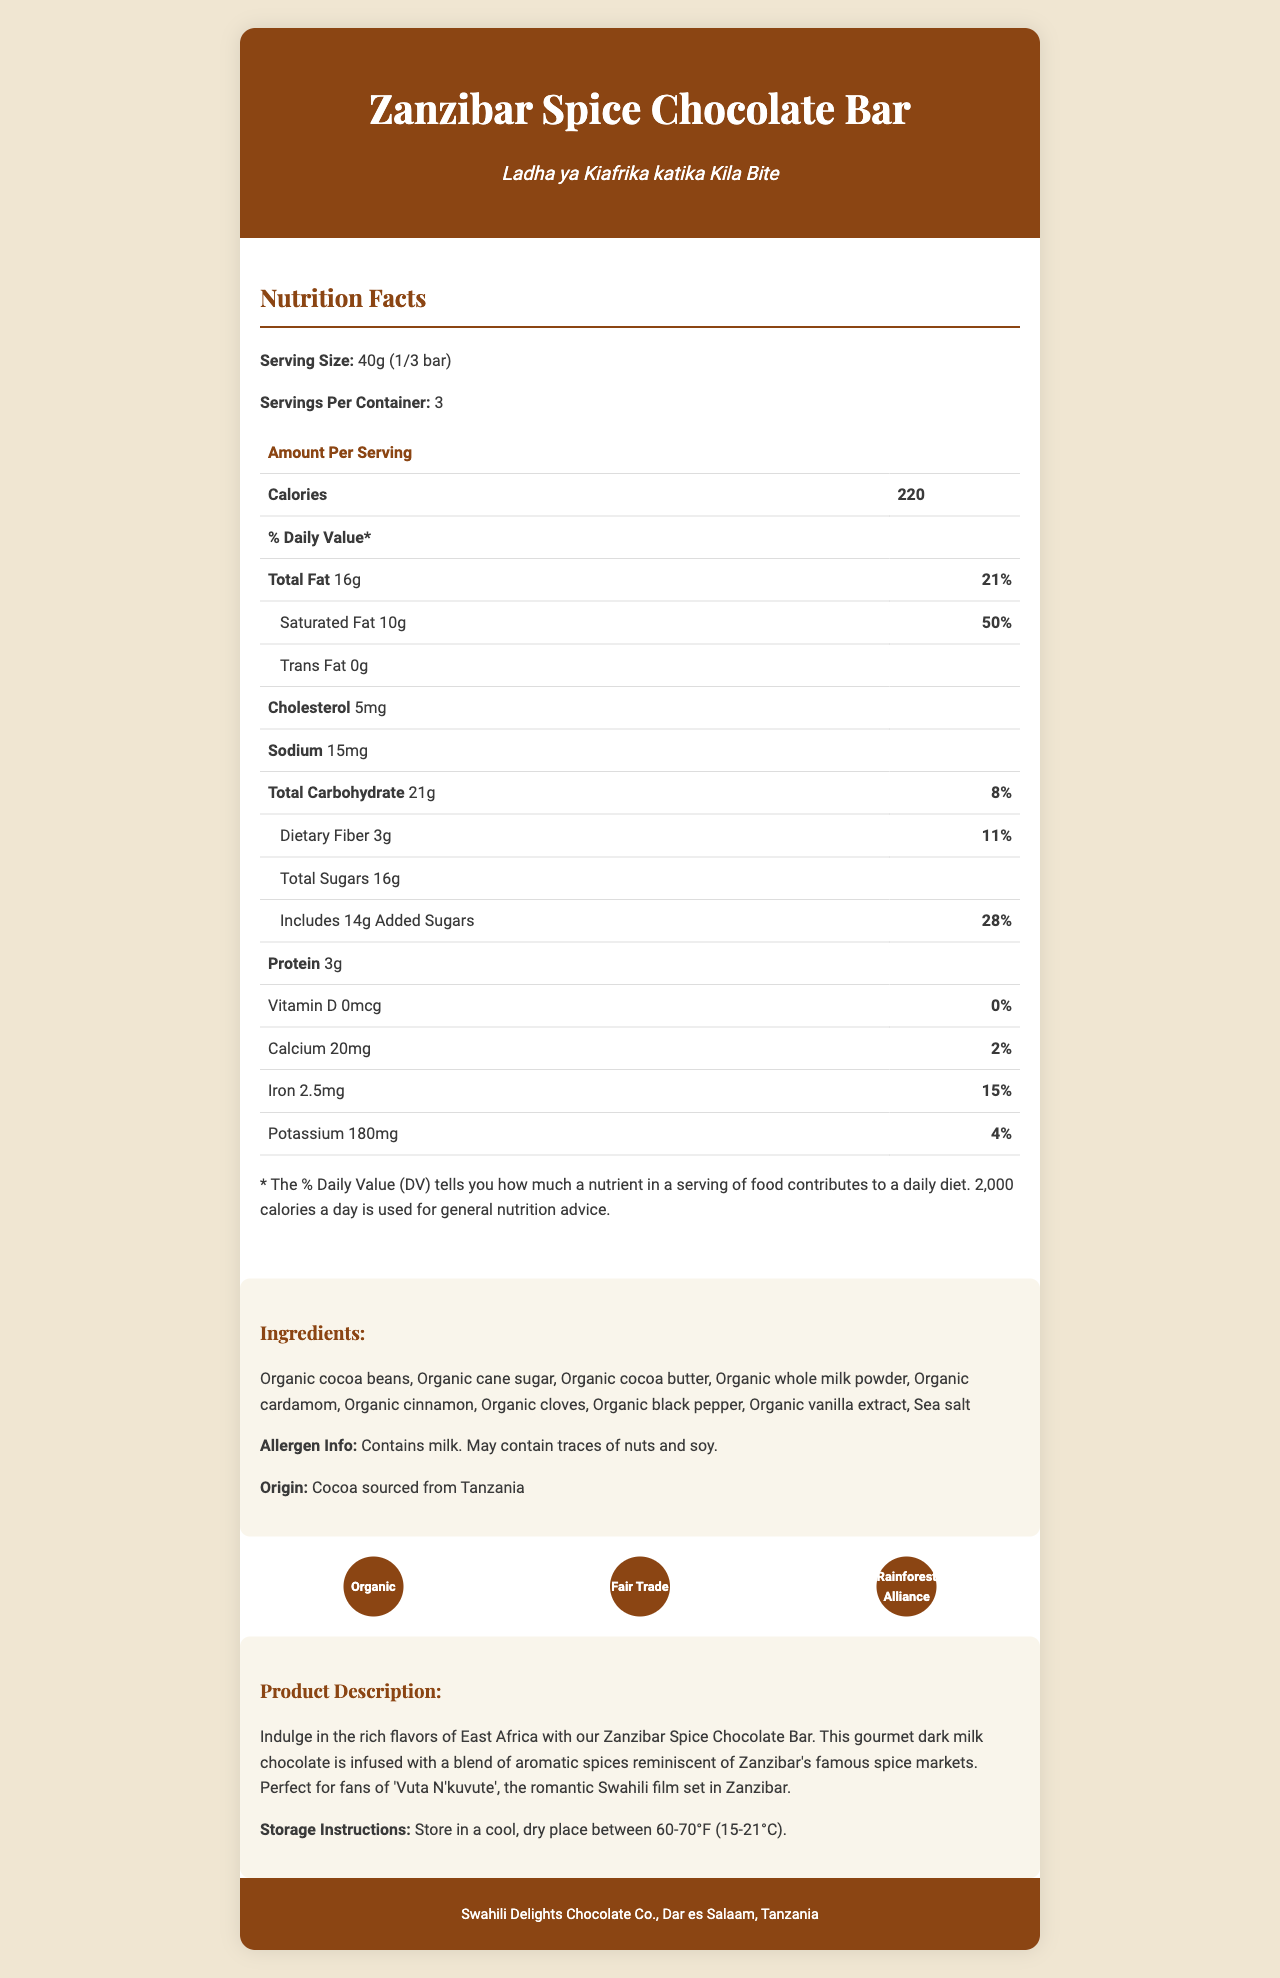what is the serving size? The serving size is mentioned at the beginning of the Nutrition Facts section.
Answer: 40g (1/3 bar) how many calories are in one serving? In the Nutrition Facts section, it specifies that one serving has 220 calories.
Answer: 220 what percentage of the daily value is the total fat per serving? The Nutrition Facts section lists the daily value percentage for total fat, which is 21%.
Answer: 21% which nutrient has the highest daily value percentage? In the Nutrition Facts section, saturated fat has the highest daily value percentage at 50%.
Answer: Saturated Fat how many grams of protein are in one serving? The amount of protein per serving is mentioned in the Nutrition Facts section.
Answer: 3g how many servings are there per container? The document states that there are 3 servings per container in the Nutrition Facts section.
Answer: 3 what is the amount of added sugars per serving? The amount of added sugars is specified as 14g per serving in the Nutrition Facts section.
Answer: 14g what are the first three ingredients listed? The ingredients list starts with these three items.
Answer: Organic cocoa beans, Organic cane sugar, Organic cocoa butter what certifications does this product have? The Certifications section mentions these three certifications.
Answer: Organic, Fair Trade, Rainforest Alliance what is the origin of the cocoa used in this chocolate bar? A. Kenya B. Tanzania C. Uganda D. Ethiopia In the ingredients section, it is mentioned that the cocoa is sourced from Tanzania.
Answer: B. Tanzania which ingredient is not in the Zanzibar Spice Chocolate Bar? A. Organic Cinnamon B. Organic Nutmeg C. Organic Black Pepper D. Sea Salt Organic Nutmeg is not listed in the ingredients section.
Answer: B. Organic Nutmeg does this product contain milk? The allergen information states that the product contains milk.
Answer: Yes summarize the entire document. The document provides detailed information about the product, including nutritional facts, ingredients, certifications, and storage instructions.
Answer: The Zanzibar Spice Chocolate Bar is a gourmet dark milk chocolate infused with East African spices. The product, made by Swahili Delights Chocolate Co. in Tanzania, offers nutritional information per serving, including calories, fat, sugars, and other nutrients. It is certified Organic, Fair Trade, and Rainforest Alliance. Ingredients, allergen information, and storage instructions are also provided. how much calcium is in a serving? The Nutrition Facts section specifies the amount of calcium per serving as 20mg.
Answer: 20mg what are the storage instructions for the chocolate bar? The storage instructions are listed at the end of the document.
Answer: Store in a cool, dry place between 60-70°F (15-21°C). what is the recommended daily calorie intake used for general nutrition advice? The Nutrition Facts section mentions that 2,000 calories a day is used for general nutrition advice.
Answer: 2,000 calories who is the manufacturer of the Zanzibar Spice Chocolate Bar? The manufacturer information is provided at the end of the document.
Answer: Swahili Delights Chocolate Co., Dar es Salaam, Tanzania what is the total amount of dietary fiber in the entire bar? There are 3 servings per container, each with 3g of dietary fiber, totaling 9g for the entire bar.
Answer: 9g who directed the Swahili film 'Vuta N'kuvute'? The document does not provide information about the director of the film 'Vuta N'kuvute'.
Answer: Cannot be determined 